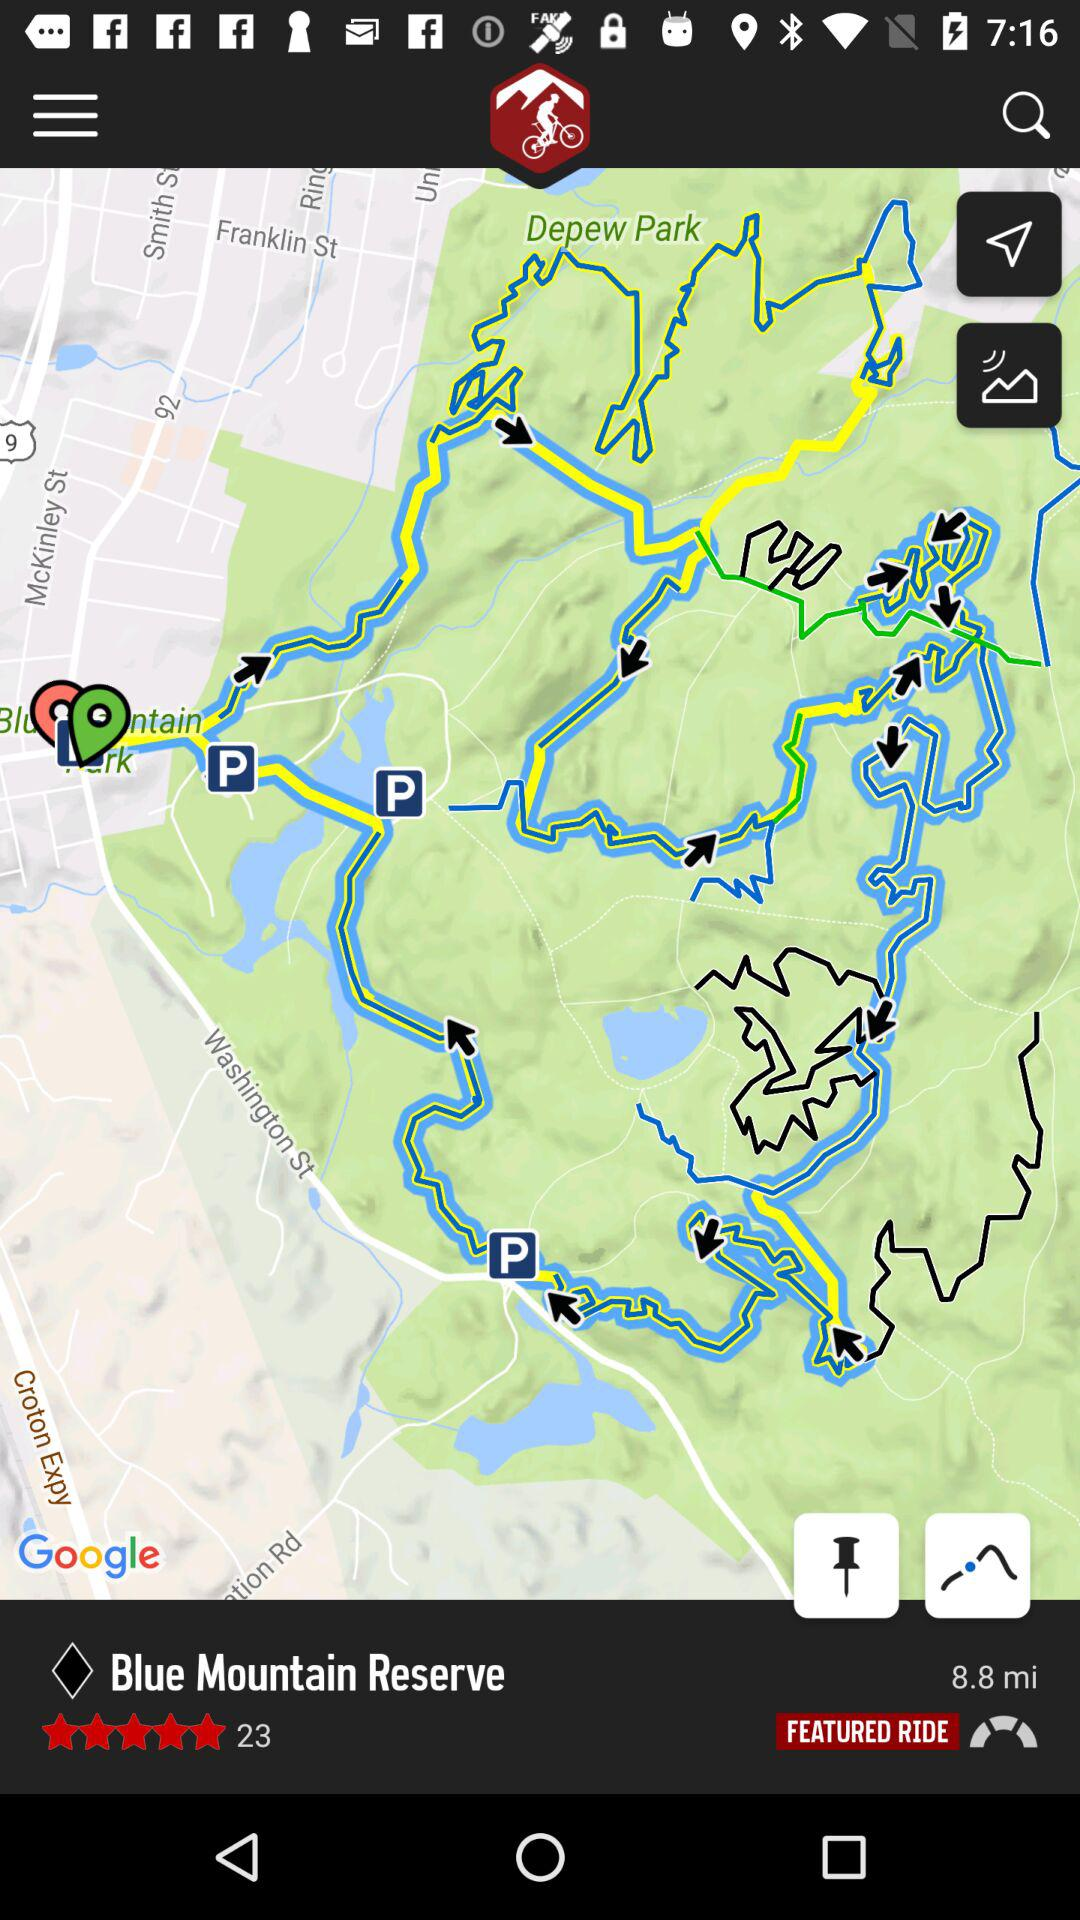How many miles are there? There are 8.8 miles. 